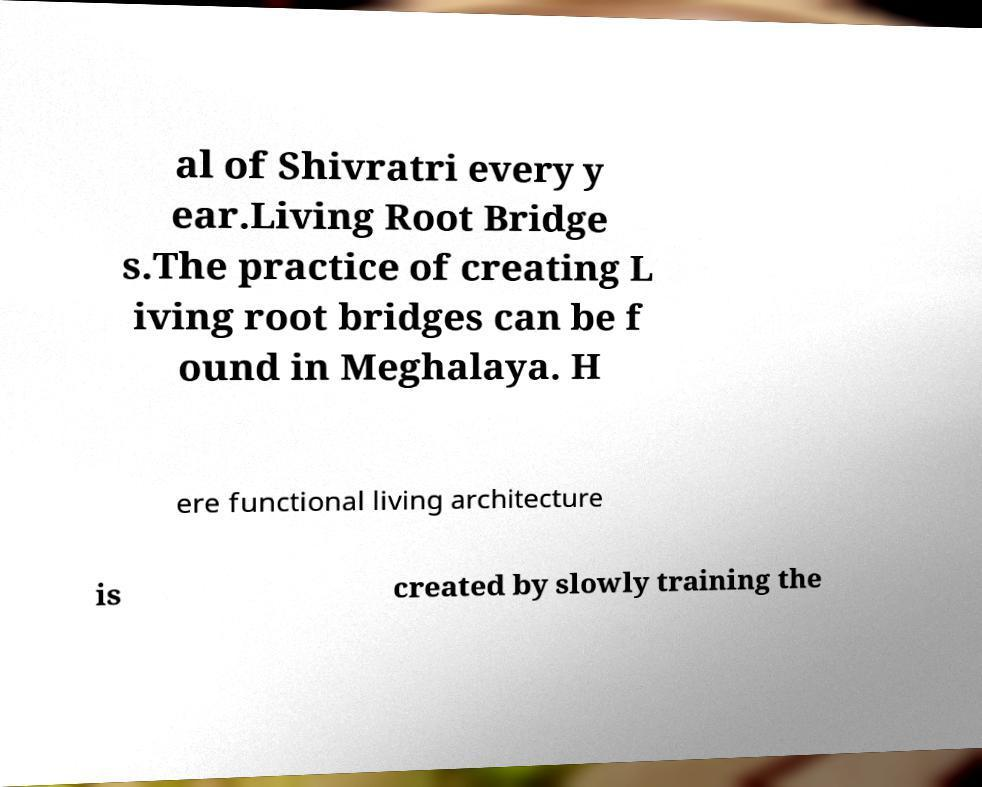Could you extract and type out the text from this image? al of Shivratri every y ear.Living Root Bridge s.The practice of creating L iving root bridges can be f ound in Meghalaya. H ere functional living architecture is created by slowly training the 